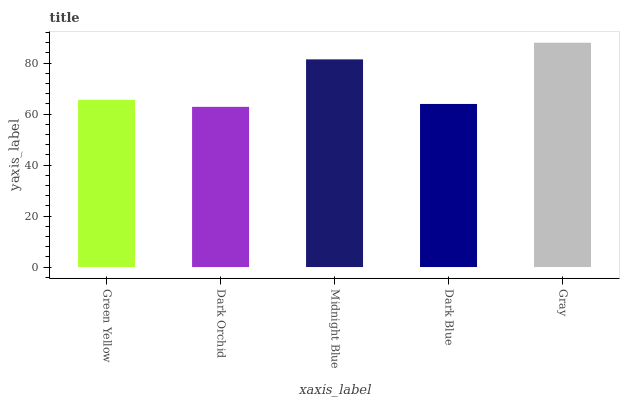Is Dark Orchid the minimum?
Answer yes or no. Yes. Is Gray the maximum?
Answer yes or no. Yes. Is Midnight Blue the minimum?
Answer yes or no. No. Is Midnight Blue the maximum?
Answer yes or no. No. Is Midnight Blue greater than Dark Orchid?
Answer yes or no. Yes. Is Dark Orchid less than Midnight Blue?
Answer yes or no. Yes. Is Dark Orchid greater than Midnight Blue?
Answer yes or no. No. Is Midnight Blue less than Dark Orchid?
Answer yes or no. No. Is Green Yellow the high median?
Answer yes or no. Yes. Is Green Yellow the low median?
Answer yes or no. Yes. Is Midnight Blue the high median?
Answer yes or no. No. Is Dark Orchid the low median?
Answer yes or no. No. 